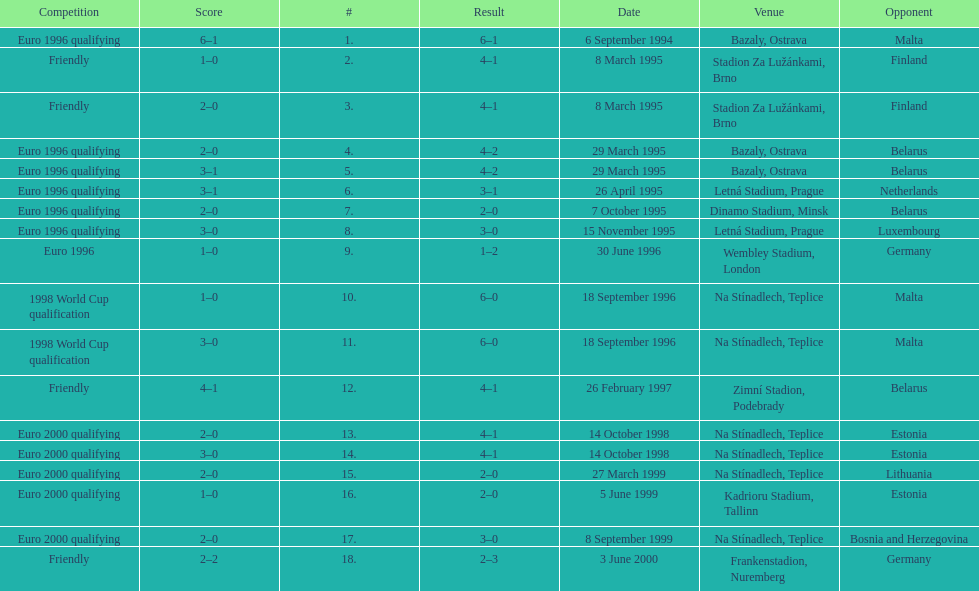How many euro 2000 qualifying competitions are listed? 4. Parse the full table. {'header': ['Competition', 'Score', '#', 'Result', 'Date', 'Venue', 'Opponent'], 'rows': [['Euro 1996 qualifying', '6–1', '1.', '6–1', '6 September 1994', 'Bazaly, Ostrava', 'Malta'], ['Friendly', '1–0', '2.', '4–1', '8 March 1995', 'Stadion Za Lužánkami, Brno', 'Finland'], ['Friendly', '2–0', '3.', '4–1', '8 March 1995', 'Stadion Za Lužánkami, Brno', 'Finland'], ['Euro 1996 qualifying', '2–0', '4.', '4–2', '29 March 1995', 'Bazaly, Ostrava', 'Belarus'], ['Euro 1996 qualifying', '3–1', '5.', '4–2', '29 March 1995', 'Bazaly, Ostrava', 'Belarus'], ['Euro 1996 qualifying', '3–1', '6.', '3–1', '26 April 1995', 'Letná Stadium, Prague', 'Netherlands'], ['Euro 1996 qualifying', '2–0', '7.', '2–0', '7 October 1995', 'Dinamo Stadium, Minsk', 'Belarus'], ['Euro 1996 qualifying', '3–0', '8.', '3–0', '15 November 1995', 'Letná Stadium, Prague', 'Luxembourg'], ['Euro 1996', '1–0', '9.', '1–2', '30 June 1996', 'Wembley Stadium, London', 'Germany'], ['1998 World Cup qualification', '1–0', '10.', '6–0', '18 September 1996', 'Na Stínadlech, Teplice', 'Malta'], ['1998 World Cup qualification', '3–0', '11.', '6–0', '18 September 1996', 'Na Stínadlech, Teplice', 'Malta'], ['Friendly', '4–1', '12.', '4–1', '26 February 1997', 'Zimní Stadion, Podebrady', 'Belarus'], ['Euro 2000 qualifying', '2–0', '13.', '4–1', '14 October 1998', 'Na Stínadlech, Teplice', 'Estonia'], ['Euro 2000 qualifying', '3–0', '14.', '4–1', '14 October 1998', 'Na Stínadlech, Teplice', 'Estonia'], ['Euro 2000 qualifying', '2–0', '15.', '2–0', '27 March 1999', 'Na Stínadlech, Teplice', 'Lithuania'], ['Euro 2000 qualifying', '1–0', '16.', '2–0', '5 June 1999', 'Kadrioru Stadium, Tallinn', 'Estonia'], ['Euro 2000 qualifying', '2–0', '17.', '3–0', '8 September 1999', 'Na Stínadlech, Teplice', 'Bosnia and Herzegovina'], ['Friendly', '2–2', '18.', '2–3', '3 June 2000', 'Frankenstadion, Nuremberg', 'Germany']]} 